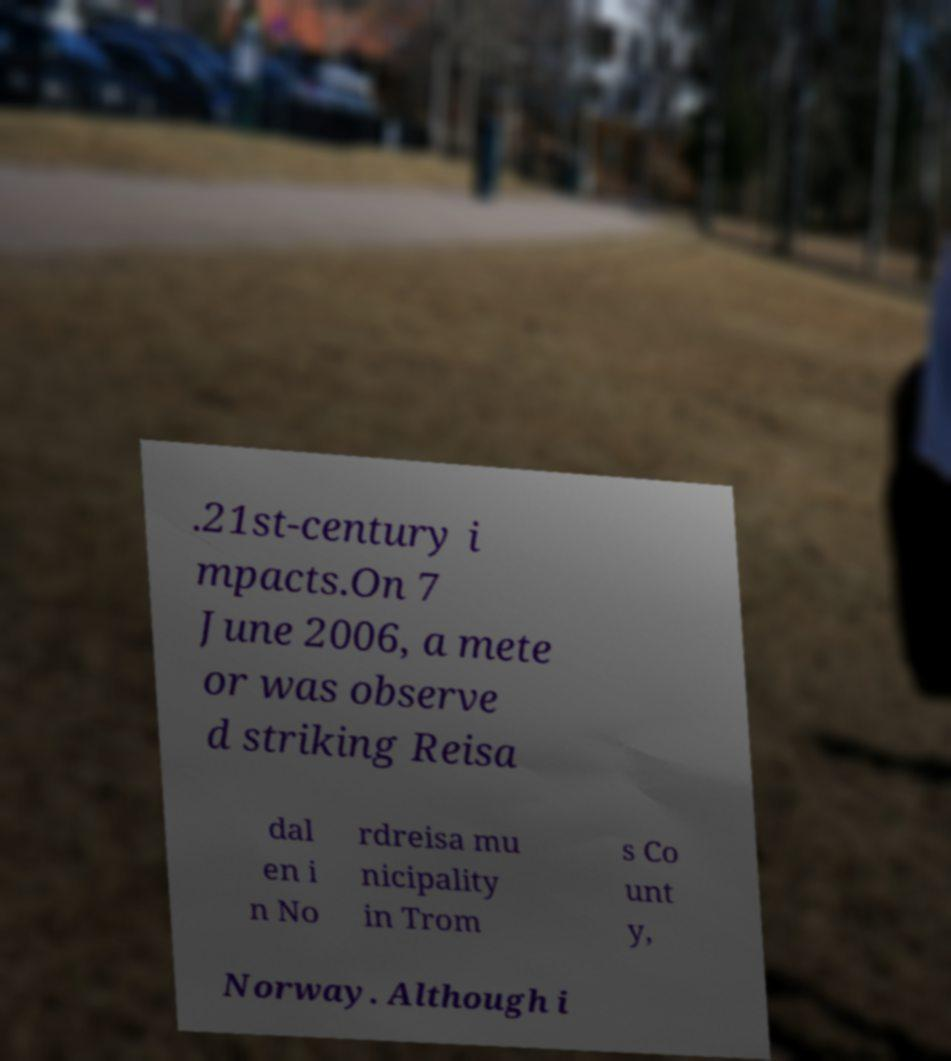Please read and relay the text visible in this image. What does it say? .21st-century i mpacts.On 7 June 2006, a mete or was observe d striking Reisa dal en i n No rdreisa mu nicipality in Trom s Co unt y, Norway. Although i 